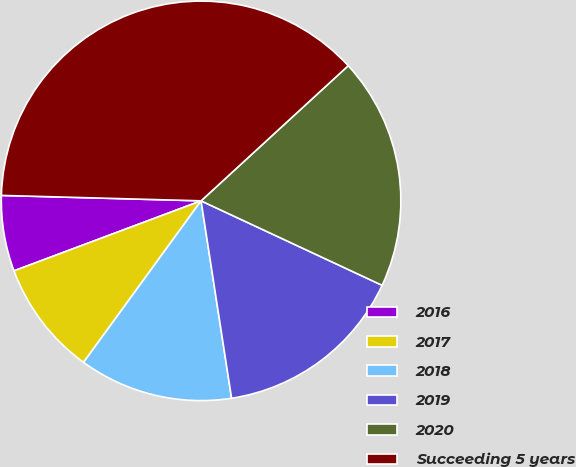Convert chart. <chart><loc_0><loc_0><loc_500><loc_500><pie_chart><fcel>2016<fcel>2017<fcel>2018<fcel>2019<fcel>2020<fcel>Succeeding 5 years<nl><fcel>6.13%<fcel>9.29%<fcel>12.45%<fcel>15.61%<fcel>18.77%<fcel>37.74%<nl></chart> 